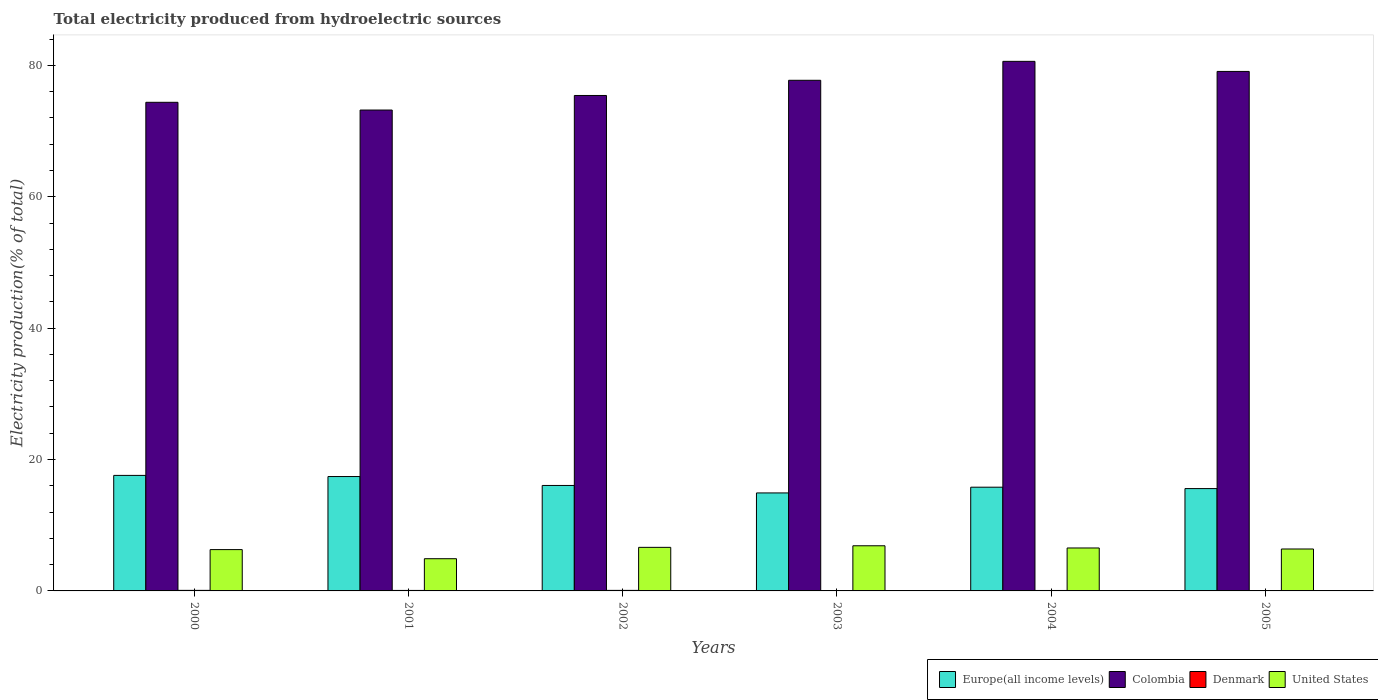How many different coloured bars are there?
Give a very brief answer. 4. How many groups of bars are there?
Your answer should be compact. 6. Are the number of bars per tick equal to the number of legend labels?
Your response must be concise. Yes. How many bars are there on the 6th tick from the left?
Your response must be concise. 4. How many bars are there on the 4th tick from the right?
Keep it short and to the point. 4. What is the total electricity produced in Denmark in 2000?
Your response must be concise. 0.08. Across all years, what is the maximum total electricity produced in Denmark?
Your response must be concise. 0.08. Across all years, what is the minimum total electricity produced in Denmark?
Your answer should be very brief. 0.05. In which year was the total electricity produced in United States maximum?
Offer a very short reply. 2003. What is the total total electricity produced in Denmark in the graph?
Ensure brevity in your answer.  0.41. What is the difference between the total electricity produced in United States in 2000 and that in 2001?
Provide a succinct answer. 1.39. What is the difference between the total electricity produced in United States in 2002 and the total electricity produced in Denmark in 2004?
Your response must be concise. 6.57. What is the average total electricity produced in Denmark per year?
Provide a short and direct response. 0.07. In the year 2002, what is the difference between the total electricity produced in Colombia and total electricity produced in United States?
Your answer should be compact. 68.78. In how many years, is the total electricity produced in Colombia greater than 20 %?
Keep it short and to the point. 6. What is the ratio of the total electricity produced in Colombia in 2001 to that in 2002?
Make the answer very short. 0.97. Is the difference between the total electricity produced in Colombia in 2000 and 2001 greater than the difference between the total electricity produced in United States in 2000 and 2001?
Keep it short and to the point. No. What is the difference between the highest and the second highest total electricity produced in Europe(all income levels)?
Your answer should be compact. 0.17. What is the difference between the highest and the lowest total electricity produced in Colombia?
Keep it short and to the point. 7.41. What does the 1st bar from the left in 2000 represents?
Keep it short and to the point. Europe(all income levels). What does the 4th bar from the right in 2002 represents?
Give a very brief answer. Europe(all income levels). How many years are there in the graph?
Your answer should be compact. 6. What is the difference between two consecutive major ticks on the Y-axis?
Your answer should be very brief. 20. Are the values on the major ticks of Y-axis written in scientific E-notation?
Provide a short and direct response. No. Does the graph contain grids?
Offer a terse response. No. How many legend labels are there?
Provide a succinct answer. 4. What is the title of the graph?
Ensure brevity in your answer.  Total electricity produced from hydroelectric sources. Does "Mongolia" appear as one of the legend labels in the graph?
Your answer should be compact. No. What is the label or title of the Y-axis?
Keep it short and to the point. Electricity production(% of total). What is the Electricity production(% of total) in Europe(all income levels) in 2000?
Your answer should be very brief. 17.58. What is the Electricity production(% of total) of Colombia in 2000?
Ensure brevity in your answer.  74.37. What is the Electricity production(% of total) in Denmark in 2000?
Offer a very short reply. 0.08. What is the Electricity production(% of total) in United States in 2000?
Your answer should be compact. 6.29. What is the Electricity production(% of total) in Europe(all income levels) in 2001?
Offer a terse response. 17.41. What is the Electricity production(% of total) in Colombia in 2001?
Your answer should be compact. 73.2. What is the Electricity production(% of total) of Denmark in 2001?
Your response must be concise. 0.07. What is the Electricity production(% of total) in United States in 2001?
Offer a terse response. 4.9. What is the Electricity production(% of total) in Europe(all income levels) in 2002?
Give a very brief answer. 16.05. What is the Electricity production(% of total) in Colombia in 2002?
Keep it short and to the point. 75.41. What is the Electricity production(% of total) in Denmark in 2002?
Make the answer very short. 0.08. What is the Electricity production(% of total) in United States in 2002?
Your response must be concise. 6.63. What is the Electricity production(% of total) in Europe(all income levels) in 2003?
Keep it short and to the point. 14.92. What is the Electricity production(% of total) of Colombia in 2003?
Offer a very short reply. 77.73. What is the Electricity production(% of total) of Denmark in 2003?
Keep it short and to the point. 0.05. What is the Electricity production(% of total) in United States in 2003?
Give a very brief answer. 6.87. What is the Electricity production(% of total) of Europe(all income levels) in 2004?
Your answer should be compact. 15.79. What is the Electricity production(% of total) in Colombia in 2004?
Give a very brief answer. 80.61. What is the Electricity production(% of total) in Denmark in 2004?
Keep it short and to the point. 0.07. What is the Electricity production(% of total) of United States in 2004?
Your answer should be very brief. 6.54. What is the Electricity production(% of total) in Europe(all income levels) in 2005?
Provide a short and direct response. 15.58. What is the Electricity production(% of total) of Colombia in 2005?
Provide a short and direct response. 79.07. What is the Electricity production(% of total) of Denmark in 2005?
Provide a succinct answer. 0.06. What is the Electricity production(% of total) of United States in 2005?
Offer a terse response. 6.38. Across all years, what is the maximum Electricity production(% of total) in Europe(all income levels)?
Offer a terse response. 17.58. Across all years, what is the maximum Electricity production(% of total) in Colombia?
Keep it short and to the point. 80.61. Across all years, what is the maximum Electricity production(% of total) in Denmark?
Offer a very short reply. 0.08. Across all years, what is the maximum Electricity production(% of total) in United States?
Make the answer very short. 6.87. Across all years, what is the minimum Electricity production(% of total) of Europe(all income levels)?
Keep it short and to the point. 14.92. Across all years, what is the minimum Electricity production(% of total) of Colombia?
Make the answer very short. 73.2. Across all years, what is the minimum Electricity production(% of total) of Denmark?
Make the answer very short. 0.05. Across all years, what is the minimum Electricity production(% of total) in United States?
Ensure brevity in your answer.  4.9. What is the total Electricity production(% of total) of Europe(all income levels) in the graph?
Provide a short and direct response. 97.33. What is the total Electricity production(% of total) in Colombia in the graph?
Provide a succinct answer. 460.39. What is the total Electricity production(% of total) of Denmark in the graph?
Provide a short and direct response. 0.41. What is the total Electricity production(% of total) of United States in the graph?
Make the answer very short. 37.61. What is the difference between the Electricity production(% of total) in Europe(all income levels) in 2000 and that in 2001?
Give a very brief answer. 0.17. What is the difference between the Electricity production(% of total) in Colombia in 2000 and that in 2001?
Provide a succinct answer. 1.18. What is the difference between the Electricity production(% of total) of Denmark in 2000 and that in 2001?
Offer a terse response. 0.01. What is the difference between the Electricity production(% of total) in United States in 2000 and that in 2001?
Offer a very short reply. 1.39. What is the difference between the Electricity production(% of total) in Europe(all income levels) in 2000 and that in 2002?
Your response must be concise. 1.53. What is the difference between the Electricity production(% of total) of Colombia in 2000 and that in 2002?
Give a very brief answer. -1.04. What is the difference between the Electricity production(% of total) in Denmark in 2000 and that in 2002?
Your answer should be very brief. 0. What is the difference between the Electricity production(% of total) of United States in 2000 and that in 2002?
Your response must be concise. -0.34. What is the difference between the Electricity production(% of total) of Europe(all income levels) in 2000 and that in 2003?
Provide a short and direct response. 2.67. What is the difference between the Electricity production(% of total) of Colombia in 2000 and that in 2003?
Ensure brevity in your answer.  -3.35. What is the difference between the Electricity production(% of total) in Denmark in 2000 and that in 2003?
Give a very brief answer. 0.04. What is the difference between the Electricity production(% of total) of United States in 2000 and that in 2003?
Offer a terse response. -0.58. What is the difference between the Electricity production(% of total) of Europe(all income levels) in 2000 and that in 2004?
Give a very brief answer. 1.8. What is the difference between the Electricity production(% of total) of Colombia in 2000 and that in 2004?
Your answer should be very brief. -6.23. What is the difference between the Electricity production(% of total) in Denmark in 2000 and that in 2004?
Provide a short and direct response. 0.02. What is the difference between the Electricity production(% of total) of United States in 2000 and that in 2004?
Your answer should be very brief. -0.25. What is the difference between the Electricity production(% of total) of Europe(all income levels) in 2000 and that in 2005?
Ensure brevity in your answer.  2.01. What is the difference between the Electricity production(% of total) of Colombia in 2000 and that in 2005?
Keep it short and to the point. -4.7. What is the difference between the Electricity production(% of total) in Denmark in 2000 and that in 2005?
Give a very brief answer. 0.02. What is the difference between the Electricity production(% of total) of United States in 2000 and that in 2005?
Give a very brief answer. -0.09. What is the difference between the Electricity production(% of total) in Europe(all income levels) in 2001 and that in 2002?
Your answer should be compact. 1.36. What is the difference between the Electricity production(% of total) of Colombia in 2001 and that in 2002?
Your answer should be compact. -2.22. What is the difference between the Electricity production(% of total) in Denmark in 2001 and that in 2002?
Make the answer very short. -0.01. What is the difference between the Electricity production(% of total) of United States in 2001 and that in 2002?
Provide a short and direct response. -1.73. What is the difference between the Electricity production(% of total) in Europe(all income levels) in 2001 and that in 2003?
Keep it short and to the point. 2.49. What is the difference between the Electricity production(% of total) of Colombia in 2001 and that in 2003?
Your response must be concise. -4.53. What is the difference between the Electricity production(% of total) of Denmark in 2001 and that in 2003?
Provide a succinct answer. 0.03. What is the difference between the Electricity production(% of total) in United States in 2001 and that in 2003?
Offer a very short reply. -1.97. What is the difference between the Electricity production(% of total) in Europe(all income levels) in 2001 and that in 2004?
Make the answer very short. 1.62. What is the difference between the Electricity production(% of total) in Colombia in 2001 and that in 2004?
Keep it short and to the point. -7.41. What is the difference between the Electricity production(% of total) of Denmark in 2001 and that in 2004?
Make the answer very short. 0.01. What is the difference between the Electricity production(% of total) of United States in 2001 and that in 2004?
Your response must be concise. -1.63. What is the difference between the Electricity production(% of total) of Europe(all income levels) in 2001 and that in 2005?
Your response must be concise. 1.83. What is the difference between the Electricity production(% of total) of Colombia in 2001 and that in 2005?
Offer a very short reply. -5.88. What is the difference between the Electricity production(% of total) in Denmark in 2001 and that in 2005?
Your response must be concise. 0.01. What is the difference between the Electricity production(% of total) in United States in 2001 and that in 2005?
Your response must be concise. -1.48. What is the difference between the Electricity production(% of total) in Europe(all income levels) in 2002 and that in 2003?
Offer a terse response. 1.14. What is the difference between the Electricity production(% of total) of Colombia in 2002 and that in 2003?
Make the answer very short. -2.31. What is the difference between the Electricity production(% of total) in Denmark in 2002 and that in 2003?
Your response must be concise. 0.04. What is the difference between the Electricity production(% of total) of United States in 2002 and that in 2003?
Your response must be concise. -0.24. What is the difference between the Electricity production(% of total) of Europe(all income levels) in 2002 and that in 2004?
Make the answer very short. 0.26. What is the difference between the Electricity production(% of total) of Colombia in 2002 and that in 2004?
Make the answer very short. -5.19. What is the difference between the Electricity production(% of total) in Denmark in 2002 and that in 2004?
Keep it short and to the point. 0.01. What is the difference between the Electricity production(% of total) in United States in 2002 and that in 2004?
Provide a succinct answer. 0.1. What is the difference between the Electricity production(% of total) in Europe(all income levels) in 2002 and that in 2005?
Provide a succinct answer. 0.47. What is the difference between the Electricity production(% of total) of Colombia in 2002 and that in 2005?
Ensure brevity in your answer.  -3.66. What is the difference between the Electricity production(% of total) of Denmark in 2002 and that in 2005?
Give a very brief answer. 0.02. What is the difference between the Electricity production(% of total) in United States in 2002 and that in 2005?
Your response must be concise. 0.25. What is the difference between the Electricity production(% of total) in Europe(all income levels) in 2003 and that in 2004?
Offer a terse response. -0.87. What is the difference between the Electricity production(% of total) of Colombia in 2003 and that in 2004?
Provide a short and direct response. -2.88. What is the difference between the Electricity production(% of total) of Denmark in 2003 and that in 2004?
Ensure brevity in your answer.  -0.02. What is the difference between the Electricity production(% of total) of United States in 2003 and that in 2004?
Ensure brevity in your answer.  0.34. What is the difference between the Electricity production(% of total) of Europe(all income levels) in 2003 and that in 2005?
Keep it short and to the point. -0.66. What is the difference between the Electricity production(% of total) of Colombia in 2003 and that in 2005?
Keep it short and to the point. -1.35. What is the difference between the Electricity production(% of total) in Denmark in 2003 and that in 2005?
Ensure brevity in your answer.  -0.02. What is the difference between the Electricity production(% of total) in United States in 2003 and that in 2005?
Your answer should be very brief. 0.49. What is the difference between the Electricity production(% of total) in Europe(all income levels) in 2004 and that in 2005?
Provide a short and direct response. 0.21. What is the difference between the Electricity production(% of total) in Colombia in 2004 and that in 2005?
Ensure brevity in your answer.  1.53. What is the difference between the Electricity production(% of total) of Denmark in 2004 and that in 2005?
Provide a short and direct response. 0. What is the difference between the Electricity production(% of total) of United States in 2004 and that in 2005?
Offer a very short reply. 0.15. What is the difference between the Electricity production(% of total) of Europe(all income levels) in 2000 and the Electricity production(% of total) of Colombia in 2001?
Your response must be concise. -55.61. What is the difference between the Electricity production(% of total) in Europe(all income levels) in 2000 and the Electricity production(% of total) in Denmark in 2001?
Your response must be concise. 17.51. What is the difference between the Electricity production(% of total) in Europe(all income levels) in 2000 and the Electricity production(% of total) in United States in 2001?
Give a very brief answer. 12.68. What is the difference between the Electricity production(% of total) in Colombia in 2000 and the Electricity production(% of total) in Denmark in 2001?
Keep it short and to the point. 74.3. What is the difference between the Electricity production(% of total) in Colombia in 2000 and the Electricity production(% of total) in United States in 2001?
Offer a very short reply. 69.47. What is the difference between the Electricity production(% of total) of Denmark in 2000 and the Electricity production(% of total) of United States in 2001?
Offer a terse response. -4.82. What is the difference between the Electricity production(% of total) of Europe(all income levels) in 2000 and the Electricity production(% of total) of Colombia in 2002?
Your response must be concise. -57.83. What is the difference between the Electricity production(% of total) in Europe(all income levels) in 2000 and the Electricity production(% of total) in Denmark in 2002?
Ensure brevity in your answer.  17.5. What is the difference between the Electricity production(% of total) in Europe(all income levels) in 2000 and the Electricity production(% of total) in United States in 2002?
Offer a very short reply. 10.95. What is the difference between the Electricity production(% of total) in Colombia in 2000 and the Electricity production(% of total) in Denmark in 2002?
Your answer should be compact. 74.29. What is the difference between the Electricity production(% of total) of Colombia in 2000 and the Electricity production(% of total) of United States in 2002?
Provide a succinct answer. 67.74. What is the difference between the Electricity production(% of total) of Denmark in 2000 and the Electricity production(% of total) of United States in 2002?
Offer a very short reply. -6.55. What is the difference between the Electricity production(% of total) of Europe(all income levels) in 2000 and the Electricity production(% of total) of Colombia in 2003?
Provide a short and direct response. -60.14. What is the difference between the Electricity production(% of total) of Europe(all income levels) in 2000 and the Electricity production(% of total) of Denmark in 2003?
Make the answer very short. 17.54. What is the difference between the Electricity production(% of total) in Europe(all income levels) in 2000 and the Electricity production(% of total) in United States in 2003?
Offer a very short reply. 10.71. What is the difference between the Electricity production(% of total) of Colombia in 2000 and the Electricity production(% of total) of Denmark in 2003?
Your response must be concise. 74.33. What is the difference between the Electricity production(% of total) in Colombia in 2000 and the Electricity production(% of total) in United States in 2003?
Offer a terse response. 67.5. What is the difference between the Electricity production(% of total) in Denmark in 2000 and the Electricity production(% of total) in United States in 2003?
Keep it short and to the point. -6.79. What is the difference between the Electricity production(% of total) of Europe(all income levels) in 2000 and the Electricity production(% of total) of Colombia in 2004?
Provide a succinct answer. -63.02. What is the difference between the Electricity production(% of total) in Europe(all income levels) in 2000 and the Electricity production(% of total) in Denmark in 2004?
Make the answer very short. 17.52. What is the difference between the Electricity production(% of total) of Europe(all income levels) in 2000 and the Electricity production(% of total) of United States in 2004?
Offer a very short reply. 11.05. What is the difference between the Electricity production(% of total) of Colombia in 2000 and the Electricity production(% of total) of Denmark in 2004?
Keep it short and to the point. 74.31. What is the difference between the Electricity production(% of total) in Colombia in 2000 and the Electricity production(% of total) in United States in 2004?
Your answer should be very brief. 67.84. What is the difference between the Electricity production(% of total) of Denmark in 2000 and the Electricity production(% of total) of United States in 2004?
Keep it short and to the point. -6.45. What is the difference between the Electricity production(% of total) of Europe(all income levels) in 2000 and the Electricity production(% of total) of Colombia in 2005?
Provide a short and direct response. -61.49. What is the difference between the Electricity production(% of total) of Europe(all income levels) in 2000 and the Electricity production(% of total) of Denmark in 2005?
Give a very brief answer. 17.52. What is the difference between the Electricity production(% of total) of Europe(all income levels) in 2000 and the Electricity production(% of total) of United States in 2005?
Provide a succinct answer. 11.2. What is the difference between the Electricity production(% of total) of Colombia in 2000 and the Electricity production(% of total) of Denmark in 2005?
Provide a succinct answer. 74.31. What is the difference between the Electricity production(% of total) in Colombia in 2000 and the Electricity production(% of total) in United States in 2005?
Offer a very short reply. 67.99. What is the difference between the Electricity production(% of total) of Denmark in 2000 and the Electricity production(% of total) of United States in 2005?
Ensure brevity in your answer.  -6.3. What is the difference between the Electricity production(% of total) of Europe(all income levels) in 2001 and the Electricity production(% of total) of Colombia in 2002?
Your response must be concise. -58. What is the difference between the Electricity production(% of total) of Europe(all income levels) in 2001 and the Electricity production(% of total) of Denmark in 2002?
Offer a very short reply. 17.33. What is the difference between the Electricity production(% of total) in Europe(all income levels) in 2001 and the Electricity production(% of total) in United States in 2002?
Your answer should be compact. 10.78. What is the difference between the Electricity production(% of total) of Colombia in 2001 and the Electricity production(% of total) of Denmark in 2002?
Offer a terse response. 73.11. What is the difference between the Electricity production(% of total) in Colombia in 2001 and the Electricity production(% of total) in United States in 2002?
Offer a very short reply. 66.56. What is the difference between the Electricity production(% of total) of Denmark in 2001 and the Electricity production(% of total) of United States in 2002?
Keep it short and to the point. -6.56. What is the difference between the Electricity production(% of total) in Europe(all income levels) in 2001 and the Electricity production(% of total) in Colombia in 2003?
Your answer should be compact. -60.32. What is the difference between the Electricity production(% of total) of Europe(all income levels) in 2001 and the Electricity production(% of total) of Denmark in 2003?
Your answer should be very brief. 17.36. What is the difference between the Electricity production(% of total) of Europe(all income levels) in 2001 and the Electricity production(% of total) of United States in 2003?
Provide a short and direct response. 10.54. What is the difference between the Electricity production(% of total) of Colombia in 2001 and the Electricity production(% of total) of Denmark in 2003?
Your response must be concise. 73.15. What is the difference between the Electricity production(% of total) in Colombia in 2001 and the Electricity production(% of total) in United States in 2003?
Your answer should be very brief. 66.33. What is the difference between the Electricity production(% of total) of Denmark in 2001 and the Electricity production(% of total) of United States in 2003?
Provide a succinct answer. -6.8. What is the difference between the Electricity production(% of total) of Europe(all income levels) in 2001 and the Electricity production(% of total) of Colombia in 2004?
Your response must be concise. -63.2. What is the difference between the Electricity production(% of total) in Europe(all income levels) in 2001 and the Electricity production(% of total) in Denmark in 2004?
Offer a very short reply. 17.34. What is the difference between the Electricity production(% of total) of Europe(all income levels) in 2001 and the Electricity production(% of total) of United States in 2004?
Provide a short and direct response. 10.87. What is the difference between the Electricity production(% of total) in Colombia in 2001 and the Electricity production(% of total) in Denmark in 2004?
Your response must be concise. 73.13. What is the difference between the Electricity production(% of total) of Colombia in 2001 and the Electricity production(% of total) of United States in 2004?
Offer a very short reply. 66.66. What is the difference between the Electricity production(% of total) of Denmark in 2001 and the Electricity production(% of total) of United States in 2004?
Offer a very short reply. -6.46. What is the difference between the Electricity production(% of total) of Europe(all income levels) in 2001 and the Electricity production(% of total) of Colombia in 2005?
Provide a succinct answer. -61.66. What is the difference between the Electricity production(% of total) of Europe(all income levels) in 2001 and the Electricity production(% of total) of Denmark in 2005?
Provide a succinct answer. 17.35. What is the difference between the Electricity production(% of total) in Europe(all income levels) in 2001 and the Electricity production(% of total) in United States in 2005?
Make the answer very short. 11.03. What is the difference between the Electricity production(% of total) of Colombia in 2001 and the Electricity production(% of total) of Denmark in 2005?
Provide a short and direct response. 73.13. What is the difference between the Electricity production(% of total) of Colombia in 2001 and the Electricity production(% of total) of United States in 2005?
Give a very brief answer. 66.81. What is the difference between the Electricity production(% of total) of Denmark in 2001 and the Electricity production(% of total) of United States in 2005?
Offer a very short reply. -6.31. What is the difference between the Electricity production(% of total) in Europe(all income levels) in 2002 and the Electricity production(% of total) in Colombia in 2003?
Provide a short and direct response. -61.67. What is the difference between the Electricity production(% of total) in Europe(all income levels) in 2002 and the Electricity production(% of total) in Denmark in 2003?
Make the answer very short. 16.01. What is the difference between the Electricity production(% of total) of Europe(all income levels) in 2002 and the Electricity production(% of total) of United States in 2003?
Make the answer very short. 9.18. What is the difference between the Electricity production(% of total) of Colombia in 2002 and the Electricity production(% of total) of Denmark in 2003?
Provide a short and direct response. 75.37. What is the difference between the Electricity production(% of total) of Colombia in 2002 and the Electricity production(% of total) of United States in 2003?
Your response must be concise. 68.54. What is the difference between the Electricity production(% of total) of Denmark in 2002 and the Electricity production(% of total) of United States in 2003?
Your answer should be compact. -6.79. What is the difference between the Electricity production(% of total) of Europe(all income levels) in 2002 and the Electricity production(% of total) of Colombia in 2004?
Make the answer very short. -64.56. What is the difference between the Electricity production(% of total) in Europe(all income levels) in 2002 and the Electricity production(% of total) in Denmark in 2004?
Offer a terse response. 15.99. What is the difference between the Electricity production(% of total) in Europe(all income levels) in 2002 and the Electricity production(% of total) in United States in 2004?
Your response must be concise. 9.52. What is the difference between the Electricity production(% of total) in Colombia in 2002 and the Electricity production(% of total) in Denmark in 2004?
Provide a short and direct response. 75.35. What is the difference between the Electricity production(% of total) in Colombia in 2002 and the Electricity production(% of total) in United States in 2004?
Ensure brevity in your answer.  68.88. What is the difference between the Electricity production(% of total) of Denmark in 2002 and the Electricity production(% of total) of United States in 2004?
Your answer should be compact. -6.45. What is the difference between the Electricity production(% of total) of Europe(all income levels) in 2002 and the Electricity production(% of total) of Colombia in 2005?
Make the answer very short. -63.02. What is the difference between the Electricity production(% of total) of Europe(all income levels) in 2002 and the Electricity production(% of total) of Denmark in 2005?
Offer a terse response. 15.99. What is the difference between the Electricity production(% of total) of Europe(all income levels) in 2002 and the Electricity production(% of total) of United States in 2005?
Give a very brief answer. 9.67. What is the difference between the Electricity production(% of total) of Colombia in 2002 and the Electricity production(% of total) of Denmark in 2005?
Provide a short and direct response. 75.35. What is the difference between the Electricity production(% of total) in Colombia in 2002 and the Electricity production(% of total) in United States in 2005?
Give a very brief answer. 69.03. What is the difference between the Electricity production(% of total) in Denmark in 2002 and the Electricity production(% of total) in United States in 2005?
Give a very brief answer. -6.3. What is the difference between the Electricity production(% of total) in Europe(all income levels) in 2003 and the Electricity production(% of total) in Colombia in 2004?
Make the answer very short. -65.69. What is the difference between the Electricity production(% of total) of Europe(all income levels) in 2003 and the Electricity production(% of total) of Denmark in 2004?
Provide a short and direct response. 14.85. What is the difference between the Electricity production(% of total) of Europe(all income levels) in 2003 and the Electricity production(% of total) of United States in 2004?
Offer a terse response. 8.38. What is the difference between the Electricity production(% of total) of Colombia in 2003 and the Electricity production(% of total) of Denmark in 2004?
Provide a short and direct response. 77.66. What is the difference between the Electricity production(% of total) in Colombia in 2003 and the Electricity production(% of total) in United States in 2004?
Offer a terse response. 71.19. What is the difference between the Electricity production(% of total) of Denmark in 2003 and the Electricity production(% of total) of United States in 2004?
Give a very brief answer. -6.49. What is the difference between the Electricity production(% of total) of Europe(all income levels) in 2003 and the Electricity production(% of total) of Colombia in 2005?
Ensure brevity in your answer.  -64.16. What is the difference between the Electricity production(% of total) of Europe(all income levels) in 2003 and the Electricity production(% of total) of Denmark in 2005?
Provide a succinct answer. 14.85. What is the difference between the Electricity production(% of total) of Europe(all income levels) in 2003 and the Electricity production(% of total) of United States in 2005?
Offer a terse response. 8.53. What is the difference between the Electricity production(% of total) in Colombia in 2003 and the Electricity production(% of total) in Denmark in 2005?
Offer a terse response. 77.66. What is the difference between the Electricity production(% of total) in Colombia in 2003 and the Electricity production(% of total) in United States in 2005?
Offer a very short reply. 71.34. What is the difference between the Electricity production(% of total) of Denmark in 2003 and the Electricity production(% of total) of United States in 2005?
Give a very brief answer. -6.34. What is the difference between the Electricity production(% of total) of Europe(all income levels) in 2004 and the Electricity production(% of total) of Colombia in 2005?
Give a very brief answer. -63.28. What is the difference between the Electricity production(% of total) of Europe(all income levels) in 2004 and the Electricity production(% of total) of Denmark in 2005?
Offer a very short reply. 15.73. What is the difference between the Electricity production(% of total) in Europe(all income levels) in 2004 and the Electricity production(% of total) in United States in 2005?
Make the answer very short. 9.41. What is the difference between the Electricity production(% of total) in Colombia in 2004 and the Electricity production(% of total) in Denmark in 2005?
Ensure brevity in your answer.  80.54. What is the difference between the Electricity production(% of total) in Colombia in 2004 and the Electricity production(% of total) in United States in 2005?
Ensure brevity in your answer.  74.22. What is the difference between the Electricity production(% of total) in Denmark in 2004 and the Electricity production(% of total) in United States in 2005?
Offer a terse response. -6.32. What is the average Electricity production(% of total) of Europe(all income levels) per year?
Keep it short and to the point. 16.22. What is the average Electricity production(% of total) of Colombia per year?
Offer a very short reply. 76.73. What is the average Electricity production(% of total) of Denmark per year?
Make the answer very short. 0.07. What is the average Electricity production(% of total) in United States per year?
Your answer should be compact. 6.27. In the year 2000, what is the difference between the Electricity production(% of total) in Europe(all income levels) and Electricity production(% of total) in Colombia?
Your response must be concise. -56.79. In the year 2000, what is the difference between the Electricity production(% of total) of Europe(all income levels) and Electricity production(% of total) of Denmark?
Provide a succinct answer. 17.5. In the year 2000, what is the difference between the Electricity production(% of total) in Europe(all income levels) and Electricity production(% of total) in United States?
Your response must be concise. 11.29. In the year 2000, what is the difference between the Electricity production(% of total) of Colombia and Electricity production(% of total) of Denmark?
Offer a terse response. 74.29. In the year 2000, what is the difference between the Electricity production(% of total) of Colombia and Electricity production(% of total) of United States?
Provide a short and direct response. 68.09. In the year 2000, what is the difference between the Electricity production(% of total) of Denmark and Electricity production(% of total) of United States?
Your response must be concise. -6.21. In the year 2001, what is the difference between the Electricity production(% of total) of Europe(all income levels) and Electricity production(% of total) of Colombia?
Your answer should be very brief. -55.79. In the year 2001, what is the difference between the Electricity production(% of total) in Europe(all income levels) and Electricity production(% of total) in Denmark?
Provide a succinct answer. 17.34. In the year 2001, what is the difference between the Electricity production(% of total) in Europe(all income levels) and Electricity production(% of total) in United States?
Offer a terse response. 12.51. In the year 2001, what is the difference between the Electricity production(% of total) of Colombia and Electricity production(% of total) of Denmark?
Provide a succinct answer. 73.12. In the year 2001, what is the difference between the Electricity production(% of total) of Colombia and Electricity production(% of total) of United States?
Offer a terse response. 68.29. In the year 2001, what is the difference between the Electricity production(% of total) in Denmark and Electricity production(% of total) in United States?
Your answer should be very brief. -4.83. In the year 2002, what is the difference between the Electricity production(% of total) in Europe(all income levels) and Electricity production(% of total) in Colombia?
Make the answer very short. -59.36. In the year 2002, what is the difference between the Electricity production(% of total) of Europe(all income levels) and Electricity production(% of total) of Denmark?
Give a very brief answer. 15.97. In the year 2002, what is the difference between the Electricity production(% of total) of Europe(all income levels) and Electricity production(% of total) of United States?
Make the answer very short. 9.42. In the year 2002, what is the difference between the Electricity production(% of total) in Colombia and Electricity production(% of total) in Denmark?
Your response must be concise. 75.33. In the year 2002, what is the difference between the Electricity production(% of total) of Colombia and Electricity production(% of total) of United States?
Provide a short and direct response. 68.78. In the year 2002, what is the difference between the Electricity production(% of total) of Denmark and Electricity production(% of total) of United States?
Your answer should be compact. -6.55. In the year 2003, what is the difference between the Electricity production(% of total) of Europe(all income levels) and Electricity production(% of total) of Colombia?
Provide a succinct answer. -62.81. In the year 2003, what is the difference between the Electricity production(% of total) in Europe(all income levels) and Electricity production(% of total) in Denmark?
Your answer should be very brief. 14.87. In the year 2003, what is the difference between the Electricity production(% of total) of Europe(all income levels) and Electricity production(% of total) of United States?
Keep it short and to the point. 8.05. In the year 2003, what is the difference between the Electricity production(% of total) of Colombia and Electricity production(% of total) of Denmark?
Your response must be concise. 77.68. In the year 2003, what is the difference between the Electricity production(% of total) in Colombia and Electricity production(% of total) in United States?
Your answer should be very brief. 70.85. In the year 2003, what is the difference between the Electricity production(% of total) of Denmark and Electricity production(% of total) of United States?
Give a very brief answer. -6.83. In the year 2004, what is the difference between the Electricity production(% of total) in Europe(all income levels) and Electricity production(% of total) in Colombia?
Your answer should be very brief. -64.82. In the year 2004, what is the difference between the Electricity production(% of total) of Europe(all income levels) and Electricity production(% of total) of Denmark?
Give a very brief answer. 15.72. In the year 2004, what is the difference between the Electricity production(% of total) in Europe(all income levels) and Electricity production(% of total) in United States?
Your answer should be compact. 9.25. In the year 2004, what is the difference between the Electricity production(% of total) in Colombia and Electricity production(% of total) in Denmark?
Offer a terse response. 80.54. In the year 2004, what is the difference between the Electricity production(% of total) in Colombia and Electricity production(% of total) in United States?
Provide a short and direct response. 74.07. In the year 2004, what is the difference between the Electricity production(% of total) of Denmark and Electricity production(% of total) of United States?
Provide a short and direct response. -6.47. In the year 2005, what is the difference between the Electricity production(% of total) in Europe(all income levels) and Electricity production(% of total) in Colombia?
Give a very brief answer. -63.5. In the year 2005, what is the difference between the Electricity production(% of total) in Europe(all income levels) and Electricity production(% of total) in Denmark?
Offer a terse response. 15.51. In the year 2005, what is the difference between the Electricity production(% of total) in Europe(all income levels) and Electricity production(% of total) in United States?
Your answer should be compact. 9.2. In the year 2005, what is the difference between the Electricity production(% of total) of Colombia and Electricity production(% of total) of Denmark?
Your answer should be compact. 79.01. In the year 2005, what is the difference between the Electricity production(% of total) in Colombia and Electricity production(% of total) in United States?
Offer a terse response. 72.69. In the year 2005, what is the difference between the Electricity production(% of total) in Denmark and Electricity production(% of total) in United States?
Make the answer very short. -6.32. What is the ratio of the Electricity production(% of total) of Europe(all income levels) in 2000 to that in 2001?
Keep it short and to the point. 1.01. What is the ratio of the Electricity production(% of total) of Colombia in 2000 to that in 2001?
Keep it short and to the point. 1.02. What is the ratio of the Electricity production(% of total) in Denmark in 2000 to that in 2001?
Provide a short and direct response. 1.12. What is the ratio of the Electricity production(% of total) of United States in 2000 to that in 2001?
Keep it short and to the point. 1.28. What is the ratio of the Electricity production(% of total) in Europe(all income levels) in 2000 to that in 2002?
Your answer should be very brief. 1.1. What is the ratio of the Electricity production(% of total) in Colombia in 2000 to that in 2002?
Make the answer very short. 0.99. What is the ratio of the Electricity production(% of total) in Denmark in 2000 to that in 2002?
Ensure brevity in your answer.  1.02. What is the ratio of the Electricity production(% of total) in United States in 2000 to that in 2002?
Give a very brief answer. 0.95. What is the ratio of the Electricity production(% of total) of Europe(all income levels) in 2000 to that in 2003?
Your answer should be very brief. 1.18. What is the ratio of the Electricity production(% of total) in Colombia in 2000 to that in 2003?
Offer a very short reply. 0.96. What is the ratio of the Electricity production(% of total) in Denmark in 2000 to that in 2003?
Provide a succinct answer. 1.83. What is the ratio of the Electricity production(% of total) of United States in 2000 to that in 2003?
Your answer should be very brief. 0.92. What is the ratio of the Electricity production(% of total) in Europe(all income levels) in 2000 to that in 2004?
Offer a terse response. 1.11. What is the ratio of the Electricity production(% of total) of Colombia in 2000 to that in 2004?
Your answer should be very brief. 0.92. What is the ratio of the Electricity production(% of total) of Denmark in 2000 to that in 2004?
Provide a short and direct response. 1.25. What is the ratio of the Electricity production(% of total) in United States in 2000 to that in 2004?
Provide a succinct answer. 0.96. What is the ratio of the Electricity production(% of total) of Europe(all income levels) in 2000 to that in 2005?
Make the answer very short. 1.13. What is the ratio of the Electricity production(% of total) in Colombia in 2000 to that in 2005?
Ensure brevity in your answer.  0.94. What is the ratio of the Electricity production(% of total) in Denmark in 2000 to that in 2005?
Your response must be concise. 1.31. What is the ratio of the Electricity production(% of total) in United States in 2000 to that in 2005?
Your answer should be very brief. 0.99. What is the ratio of the Electricity production(% of total) of Europe(all income levels) in 2001 to that in 2002?
Offer a terse response. 1.08. What is the ratio of the Electricity production(% of total) in Colombia in 2001 to that in 2002?
Provide a succinct answer. 0.97. What is the ratio of the Electricity production(% of total) in Denmark in 2001 to that in 2002?
Your response must be concise. 0.91. What is the ratio of the Electricity production(% of total) of United States in 2001 to that in 2002?
Your response must be concise. 0.74. What is the ratio of the Electricity production(% of total) of Europe(all income levels) in 2001 to that in 2003?
Give a very brief answer. 1.17. What is the ratio of the Electricity production(% of total) of Colombia in 2001 to that in 2003?
Keep it short and to the point. 0.94. What is the ratio of the Electricity production(% of total) in Denmark in 2001 to that in 2003?
Make the answer very short. 1.63. What is the ratio of the Electricity production(% of total) in United States in 2001 to that in 2003?
Ensure brevity in your answer.  0.71. What is the ratio of the Electricity production(% of total) in Europe(all income levels) in 2001 to that in 2004?
Your response must be concise. 1.1. What is the ratio of the Electricity production(% of total) in Colombia in 2001 to that in 2004?
Ensure brevity in your answer.  0.91. What is the ratio of the Electricity production(% of total) of Denmark in 2001 to that in 2004?
Your response must be concise. 1.11. What is the ratio of the Electricity production(% of total) in United States in 2001 to that in 2004?
Make the answer very short. 0.75. What is the ratio of the Electricity production(% of total) in Europe(all income levels) in 2001 to that in 2005?
Your answer should be compact. 1.12. What is the ratio of the Electricity production(% of total) of Colombia in 2001 to that in 2005?
Give a very brief answer. 0.93. What is the ratio of the Electricity production(% of total) of Denmark in 2001 to that in 2005?
Make the answer very short. 1.17. What is the ratio of the Electricity production(% of total) in United States in 2001 to that in 2005?
Give a very brief answer. 0.77. What is the ratio of the Electricity production(% of total) of Europe(all income levels) in 2002 to that in 2003?
Give a very brief answer. 1.08. What is the ratio of the Electricity production(% of total) in Colombia in 2002 to that in 2003?
Make the answer very short. 0.97. What is the ratio of the Electricity production(% of total) of Denmark in 2002 to that in 2003?
Offer a very short reply. 1.79. What is the ratio of the Electricity production(% of total) in United States in 2002 to that in 2003?
Your answer should be very brief. 0.97. What is the ratio of the Electricity production(% of total) of Europe(all income levels) in 2002 to that in 2004?
Keep it short and to the point. 1.02. What is the ratio of the Electricity production(% of total) in Colombia in 2002 to that in 2004?
Ensure brevity in your answer.  0.94. What is the ratio of the Electricity production(% of total) of Denmark in 2002 to that in 2004?
Offer a very short reply. 1.22. What is the ratio of the Electricity production(% of total) of United States in 2002 to that in 2004?
Give a very brief answer. 1.01. What is the ratio of the Electricity production(% of total) of Europe(all income levels) in 2002 to that in 2005?
Your answer should be compact. 1.03. What is the ratio of the Electricity production(% of total) in Colombia in 2002 to that in 2005?
Ensure brevity in your answer.  0.95. What is the ratio of the Electricity production(% of total) of Denmark in 2002 to that in 2005?
Make the answer very short. 1.28. What is the ratio of the Electricity production(% of total) of United States in 2002 to that in 2005?
Provide a succinct answer. 1.04. What is the ratio of the Electricity production(% of total) in Europe(all income levels) in 2003 to that in 2004?
Your response must be concise. 0.94. What is the ratio of the Electricity production(% of total) of Colombia in 2003 to that in 2004?
Make the answer very short. 0.96. What is the ratio of the Electricity production(% of total) of Denmark in 2003 to that in 2004?
Ensure brevity in your answer.  0.68. What is the ratio of the Electricity production(% of total) of United States in 2003 to that in 2004?
Your answer should be very brief. 1.05. What is the ratio of the Electricity production(% of total) of Europe(all income levels) in 2003 to that in 2005?
Your answer should be compact. 0.96. What is the ratio of the Electricity production(% of total) in Denmark in 2003 to that in 2005?
Offer a very short reply. 0.72. What is the ratio of the Electricity production(% of total) of United States in 2003 to that in 2005?
Give a very brief answer. 1.08. What is the ratio of the Electricity production(% of total) in Europe(all income levels) in 2004 to that in 2005?
Ensure brevity in your answer.  1.01. What is the ratio of the Electricity production(% of total) in Colombia in 2004 to that in 2005?
Your answer should be very brief. 1.02. What is the ratio of the Electricity production(% of total) in Denmark in 2004 to that in 2005?
Offer a terse response. 1.05. What is the ratio of the Electricity production(% of total) of United States in 2004 to that in 2005?
Your answer should be compact. 1.02. What is the difference between the highest and the second highest Electricity production(% of total) of Europe(all income levels)?
Your answer should be very brief. 0.17. What is the difference between the highest and the second highest Electricity production(% of total) of Colombia?
Offer a very short reply. 1.53. What is the difference between the highest and the second highest Electricity production(% of total) of Denmark?
Keep it short and to the point. 0. What is the difference between the highest and the second highest Electricity production(% of total) of United States?
Give a very brief answer. 0.24. What is the difference between the highest and the lowest Electricity production(% of total) in Europe(all income levels)?
Provide a succinct answer. 2.67. What is the difference between the highest and the lowest Electricity production(% of total) in Colombia?
Offer a terse response. 7.41. What is the difference between the highest and the lowest Electricity production(% of total) in Denmark?
Give a very brief answer. 0.04. What is the difference between the highest and the lowest Electricity production(% of total) in United States?
Provide a succinct answer. 1.97. 